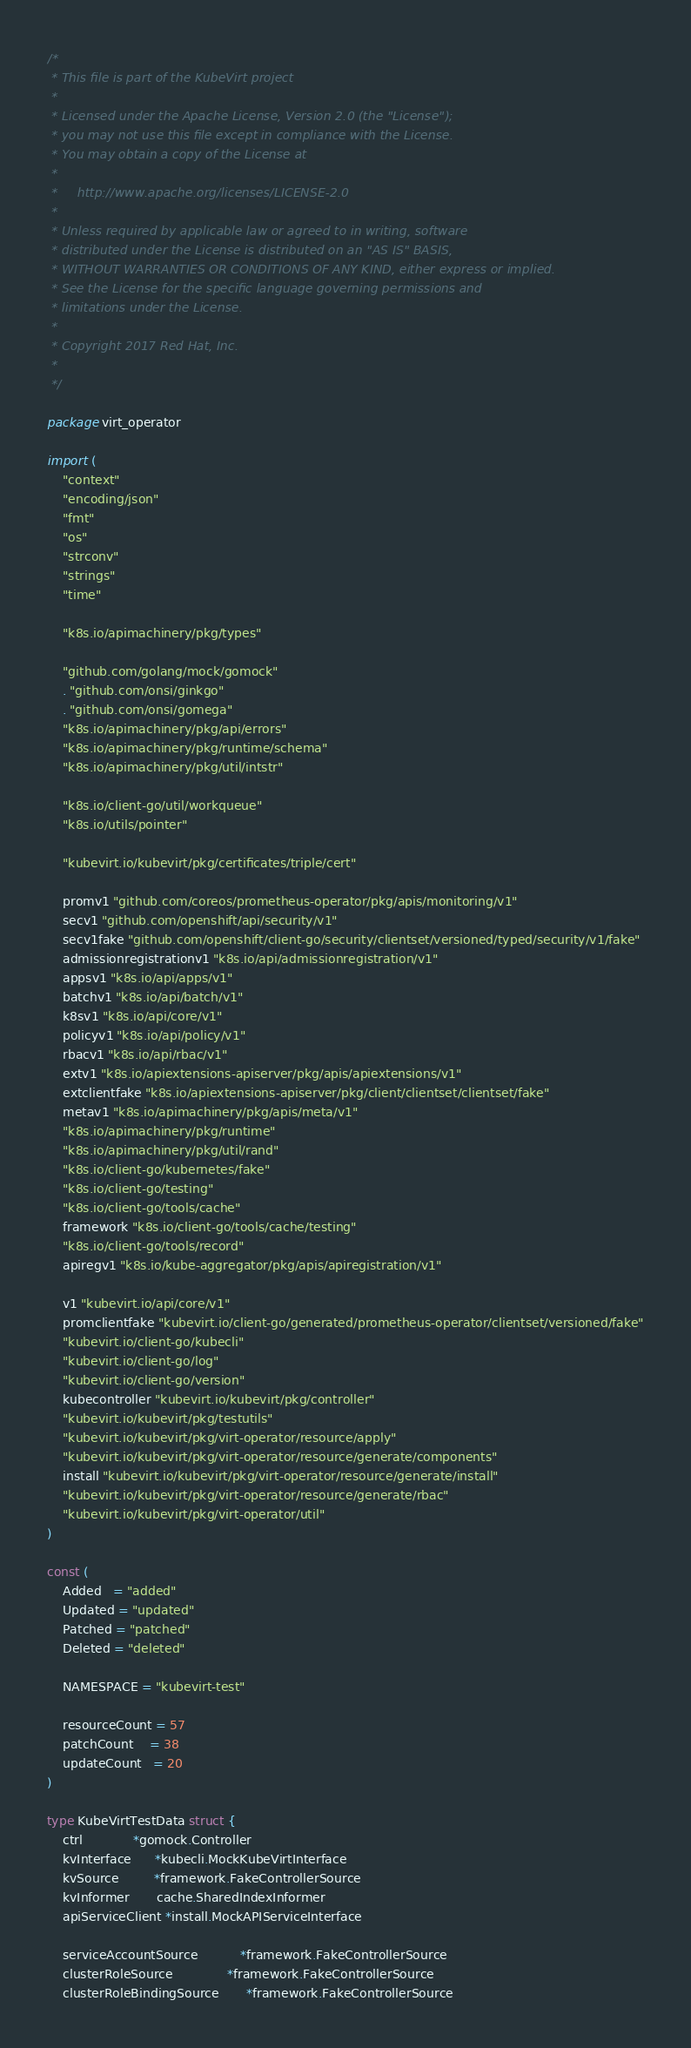Convert code to text. <code><loc_0><loc_0><loc_500><loc_500><_Go_>/*
 * This file is part of the KubeVirt project
 *
 * Licensed under the Apache License, Version 2.0 (the "License");
 * you may not use this file except in compliance with the License.
 * You may obtain a copy of the License at
 *
 *     http://www.apache.org/licenses/LICENSE-2.0
 *
 * Unless required by applicable law or agreed to in writing, software
 * distributed under the License is distributed on an "AS IS" BASIS,
 * WITHOUT WARRANTIES OR CONDITIONS OF ANY KIND, either express or implied.
 * See the License for the specific language governing permissions and
 * limitations under the License.
 *
 * Copyright 2017 Red Hat, Inc.
 *
 */

package virt_operator

import (
	"context"
	"encoding/json"
	"fmt"
	"os"
	"strconv"
	"strings"
	"time"

	"k8s.io/apimachinery/pkg/types"

	"github.com/golang/mock/gomock"
	. "github.com/onsi/ginkgo"
	. "github.com/onsi/gomega"
	"k8s.io/apimachinery/pkg/api/errors"
	"k8s.io/apimachinery/pkg/runtime/schema"
	"k8s.io/apimachinery/pkg/util/intstr"

	"k8s.io/client-go/util/workqueue"
	"k8s.io/utils/pointer"

	"kubevirt.io/kubevirt/pkg/certificates/triple/cert"

	promv1 "github.com/coreos/prometheus-operator/pkg/apis/monitoring/v1"
	secv1 "github.com/openshift/api/security/v1"
	secv1fake "github.com/openshift/client-go/security/clientset/versioned/typed/security/v1/fake"
	admissionregistrationv1 "k8s.io/api/admissionregistration/v1"
	appsv1 "k8s.io/api/apps/v1"
	batchv1 "k8s.io/api/batch/v1"
	k8sv1 "k8s.io/api/core/v1"
	policyv1 "k8s.io/api/policy/v1"
	rbacv1 "k8s.io/api/rbac/v1"
	extv1 "k8s.io/apiextensions-apiserver/pkg/apis/apiextensions/v1"
	extclientfake "k8s.io/apiextensions-apiserver/pkg/client/clientset/clientset/fake"
	metav1 "k8s.io/apimachinery/pkg/apis/meta/v1"
	"k8s.io/apimachinery/pkg/runtime"
	"k8s.io/apimachinery/pkg/util/rand"
	"k8s.io/client-go/kubernetes/fake"
	"k8s.io/client-go/testing"
	"k8s.io/client-go/tools/cache"
	framework "k8s.io/client-go/tools/cache/testing"
	"k8s.io/client-go/tools/record"
	apiregv1 "k8s.io/kube-aggregator/pkg/apis/apiregistration/v1"

	v1 "kubevirt.io/api/core/v1"
	promclientfake "kubevirt.io/client-go/generated/prometheus-operator/clientset/versioned/fake"
	"kubevirt.io/client-go/kubecli"
	"kubevirt.io/client-go/log"
	"kubevirt.io/client-go/version"
	kubecontroller "kubevirt.io/kubevirt/pkg/controller"
	"kubevirt.io/kubevirt/pkg/testutils"
	"kubevirt.io/kubevirt/pkg/virt-operator/resource/apply"
	"kubevirt.io/kubevirt/pkg/virt-operator/resource/generate/components"
	install "kubevirt.io/kubevirt/pkg/virt-operator/resource/generate/install"
	"kubevirt.io/kubevirt/pkg/virt-operator/resource/generate/rbac"
	"kubevirt.io/kubevirt/pkg/virt-operator/util"
)

const (
	Added   = "added"
	Updated = "updated"
	Patched = "patched"
	Deleted = "deleted"

	NAMESPACE = "kubevirt-test"

	resourceCount = 57
	patchCount    = 38
	updateCount   = 20
)

type KubeVirtTestData struct {
	ctrl             *gomock.Controller
	kvInterface      *kubecli.MockKubeVirtInterface
	kvSource         *framework.FakeControllerSource
	kvInformer       cache.SharedIndexInformer
	apiServiceClient *install.MockAPIServiceInterface

	serviceAccountSource           *framework.FakeControllerSource
	clusterRoleSource              *framework.FakeControllerSource
	clusterRoleBindingSource       *framework.FakeControllerSource</code> 